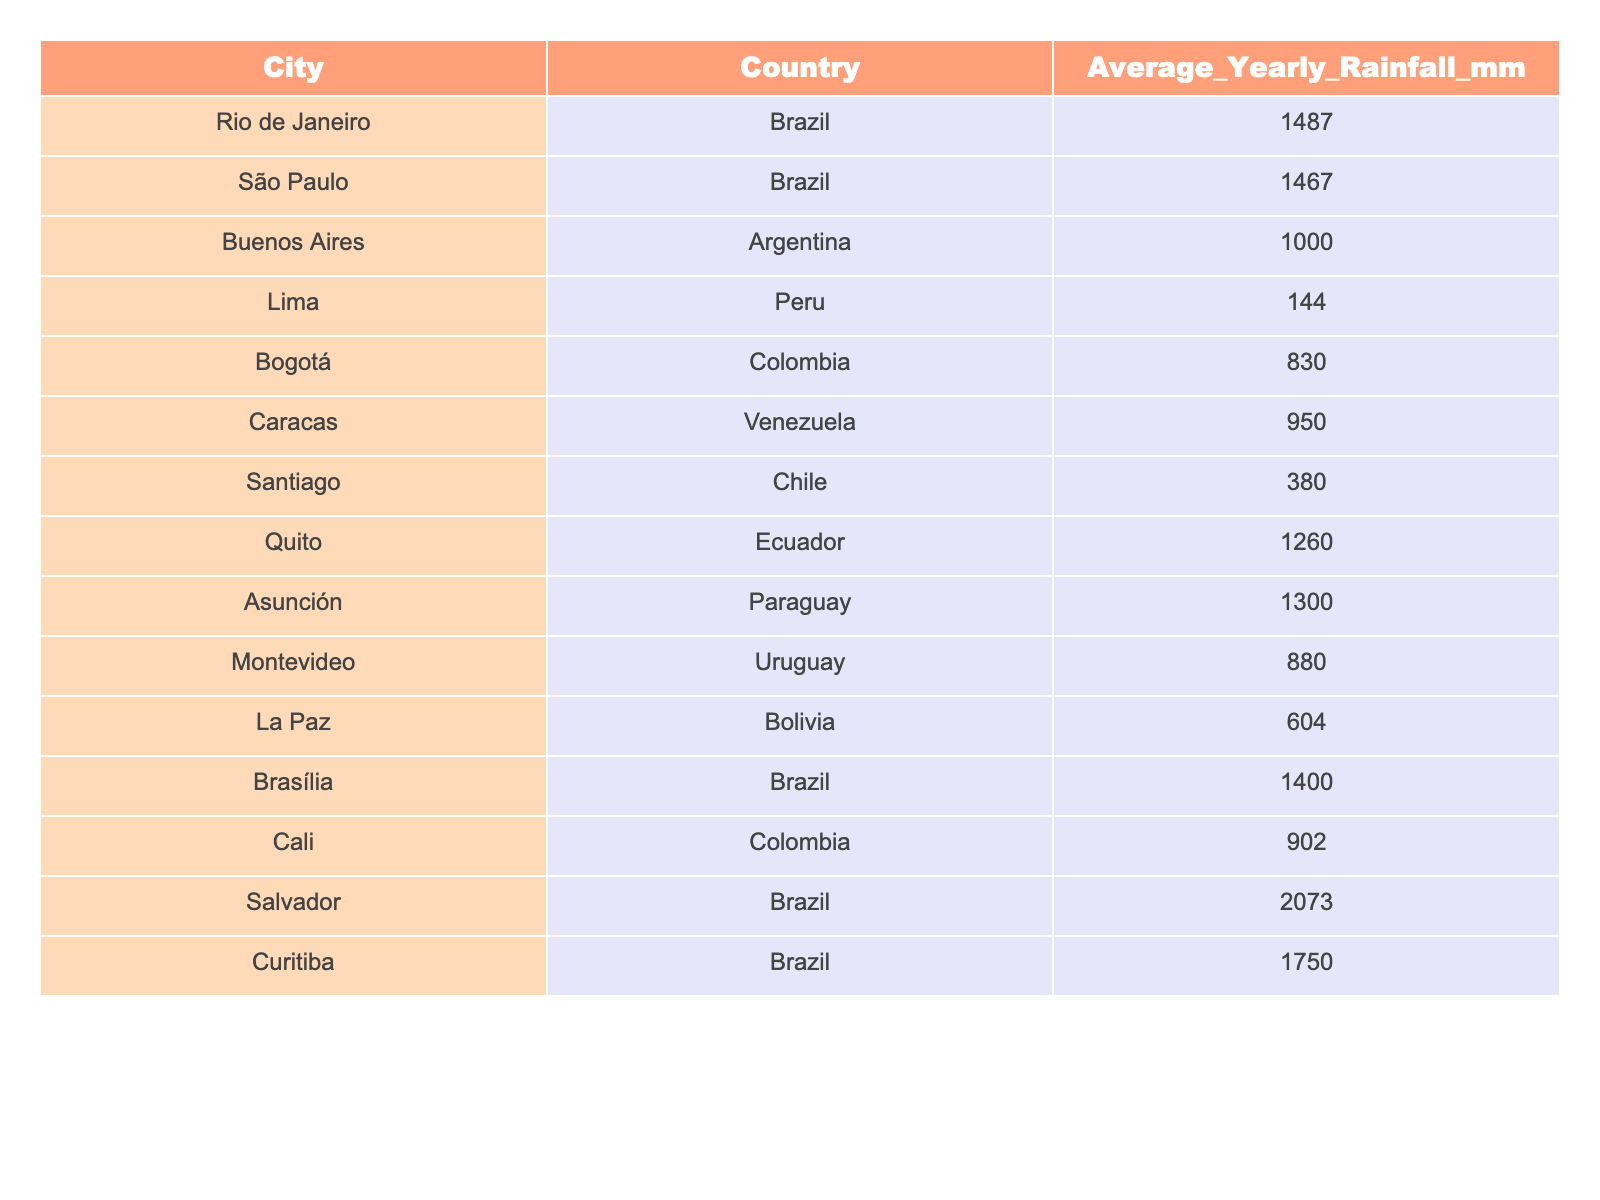What city has the highest average yearly rainfall? By looking at the table, I can see that Salvador, Brazil has the highest average yearly rainfall at 2073 mm.
Answer: 2073 mm Which city has the lowest average yearly rainfall? Lima, Peru shows the lowest average yearly rainfall, recorded at 144 mm, as per the table.
Answer: 144 mm How much more rainfall does Rio de Janeiro receive compared to Santiago? The average rainfall for Rio de Janeiro is 1487 mm, and for Santiago it is 380 mm. So, the difference is 1487 - 380 = 1107 mm.
Answer: 1107 mm What is the average rainfall of all listed cities combined? To find the average, I would sum up all the cities' average yearly rainfalls: (1487 + 1467 + 1000 + 144 + 830 + 950 + 380 + 1260 + 1300 + 880 + 604 + 1400 + 902 + 2073 + 1750) = 14270 mm. There are 14 cities, so I divide by 14: 14270 / 14 ≈ 1019.29 mm.
Answer: 1019.29 mm Is Bogotá receiving more rainfall than Caracas? Bogotá has an average yearly rainfall of 830 mm, while Caracas has 950 mm, so Bogotá does not receive more rainfall than Caracas.
Answer: No Which country has the wettest city according to this table? Salvador in Brazil has the highest rainfall of 2073 mm, making Brazil the country with the wettest city.
Answer: Brazil What is the difference in rainfall between the two cities with the highest rainfall? The highest rainfall is in Salvador (2073 mm) and the second highest is Curitiba (1750 mm). The difference is 2073 - 1750 = 323 mm.
Answer: 323 mm Find the median rainfall amount from the dataset. To find the median, I list the rainfalls in ascending order: 144, 380, 604, 650, 880, 902, 1000, 1260, 1300, 1400, 1467, 1487, 1750, 2073. There are 14 values, so the median is the average of the 7th and 8th values: (1000 + 1260) / 2 = 1130 mm.
Answer: 1130 mm 